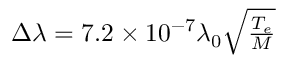Convert formula to latex. <formula><loc_0><loc_0><loc_500><loc_500>\begin{array} { r } { \Delta \lambda = 7 . 2 \times 1 0 ^ { - 7 } \lambda _ { 0 } \sqrt { \frac { T _ { e } } { M } } } \end{array}</formula> 